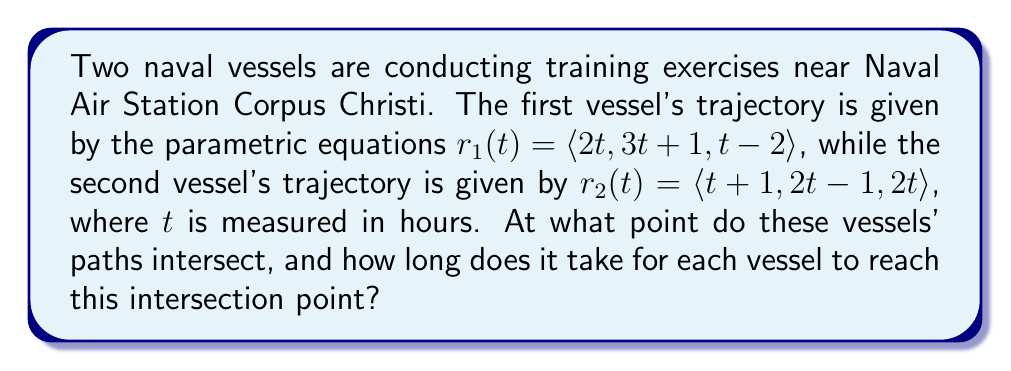Can you answer this question? To find the intersection point of the two vessels' trajectories, we need to equate their parametric equations and solve for the parameters:

1) Equate the x-components:
   $2t_1 = t_2 + 1$

2) Equate the y-components:
   $3t_1 + 1 = 2t_2 - 1$

3) Equate the z-components:
   $t_1 - 2 = 2t_2$

From equation 3:
$t_1 = 2t_2 + 2$

Substitute this into equation 1:
$2(2t_2 + 2) = t_2 + 1$
$4t_2 + 4 = t_2 + 1$
$3t_2 = -3$
$t_2 = -1$

Now substitute $t_2 = -1$ back into equation 1:
$2t_1 = -1 + 1$
$2t_1 = 0$
$t_1 = 0$

To verify, let's check if these values satisfy equation 2:
$3(0) + 1 = 2(-1) - 1$
$1 = -3$

This is not true, so there is no intersection point that satisfies all three equations simultaneously.

However, in naval operations, we typically consider only the x and y coordinates for surface vessel positions. If we ignore the z-component, we can find an intersection point in the xy-plane.

Using $t_1 = 0$ and $t_2 = -1$, we can calculate the intersection point:

For vessel 1: $r_1(0) = \langle 2(0), 3(0)+1, 0-2 \rangle = \langle 0, 1, -2 \rangle$
For vessel 2: $r_2(-1) = \langle -1+1, 2(-1)-1, 2(-1) \rangle = \langle 0, -3, -2 \rangle$

The xy-coordinates match at $\langle 0, 1 \rangle$.
Answer: The vessels' paths intersect at the point $(0, 1)$ in the xy-plane. Vessel 1 reaches this point at $t_1 = 0$ hours, while Vessel 2 reaches this point at $t_2 = -1$ hours. Note that this intersection only considers the x and y coordinates, ignoring the z-component. 